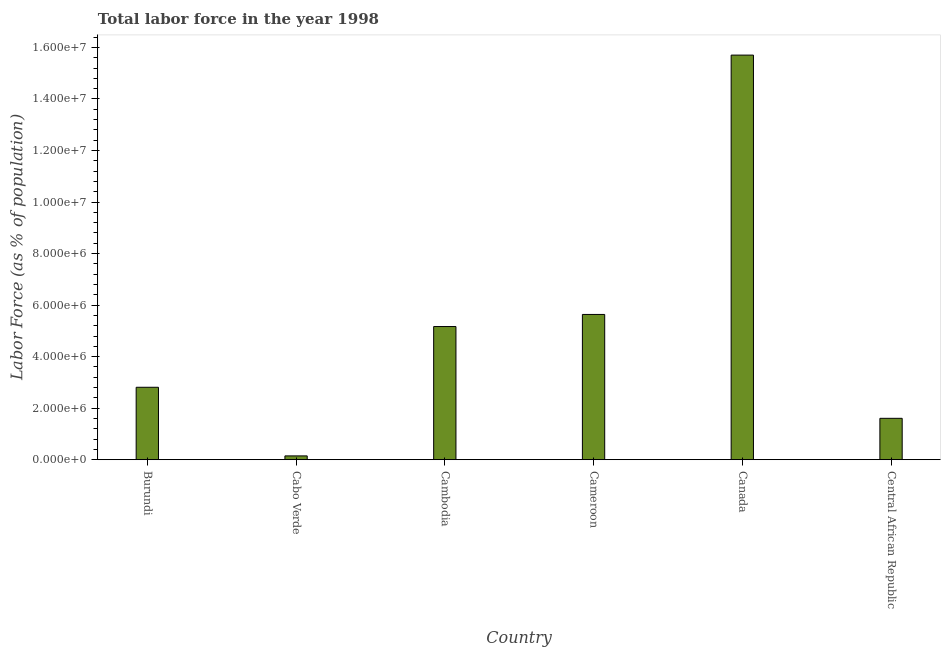Does the graph contain any zero values?
Keep it short and to the point. No. What is the title of the graph?
Your response must be concise. Total labor force in the year 1998. What is the label or title of the Y-axis?
Your answer should be very brief. Labor Force (as % of population). What is the total labor force in Cameroon?
Give a very brief answer. 5.64e+06. Across all countries, what is the maximum total labor force?
Give a very brief answer. 1.57e+07. Across all countries, what is the minimum total labor force?
Make the answer very short. 1.48e+05. In which country was the total labor force minimum?
Provide a succinct answer. Cabo Verde. What is the sum of the total labor force?
Offer a terse response. 3.11e+07. What is the difference between the total labor force in Cambodia and Cameroon?
Provide a short and direct response. -4.70e+05. What is the average total labor force per country?
Provide a short and direct response. 5.18e+06. What is the median total labor force?
Your answer should be compact. 3.99e+06. What is the ratio of the total labor force in Cambodia to that in Cameroon?
Your answer should be very brief. 0.92. Is the total labor force in Canada less than that in Central African Republic?
Offer a terse response. No. What is the difference between the highest and the second highest total labor force?
Give a very brief answer. 1.01e+07. Is the sum of the total labor force in Cabo Verde and Cambodia greater than the maximum total labor force across all countries?
Offer a very short reply. No. What is the difference between the highest and the lowest total labor force?
Your answer should be very brief. 1.56e+07. In how many countries, is the total labor force greater than the average total labor force taken over all countries?
Ensure brevity in your answer.  2. How many bars are there?
Your response must be concise. 6. Are all the bars in the graph horizontal?
Give a very brief answer. No. How many countries are there in the graph?
Your response must be concise. 6. Are the values on the major ticks of Y-axis written in scientific E-notation?
Your answer should be very brief. Yes. What is the Labor Force (as % of population) of Burundi?
Offer a terse response. 2.81e+06. What is the Labor Force (as % of population) of Cabo Verde?
Keep it short and to the point. 1.48e+05. What is the Labor Force (as % of population) of Cambodia?
Keep it short and to the point. 5.17e+06. What is the Labor Force (as % of population) in Cameroon?
Provide a succinct answer. 5.64e+06. What is the Labor Force (as % of population) of Canada?
Provide a succinct answer. 1.57e+07. What is the Labor Force (as % of population) in Central African Republic?
Provide a short and direct response. 1.61e+06. What is the difference between the Labor Force (as % of population) in Burundi and Cabo Verde?
Keep it short and to the point. 2.66e+06. What is the difference between the Labor Force (as % of population) in Burundi and Cambodia?
Ensure brevity in your answer.  -2.36e+06. What is the difference between the Labor Force (as % of population) in Burundi and Cameroon?
Ensure brevity in your answer.  -2.83e+06. What is the difference between the Labor Force (as % of population) in Burundi and Canada?
Offer a terse response. -1.29e+07. What is the difference between the Labor Force (as % of population) in Burundi and Central African Republic?
Provide a short and direct response. 1.21e+06. What is the difference between the Labor Force (as % of population) in Cabo Verde and Cambodia?
Your answer should be very brief. -5.02e+06. What is the difference between the Labor Force (as % of population) in Cabo Verde and Cameroon?
Your answer should be compact. -5.49e+06. What is the difference between the Labor Force (as % of population) in Cabo Verde and Canada?
Ensure brevity in your answer.  -1.56e+07. What is the difference between the Labor Force (as % of population) in Cabo Verde and Central African Republic?
Keep it short and to the point. -1.46e+06. What is the difference between the Labor Force (as % of population) in Cambodia and Cameroon?
Ensure brevity in your answer.  -4.70e+05. What is the difference between the Labor Force (as % of population) in Cambodia and Canada?
Offer a very short reply. -1.05e+07. What is the difference between the Labor Force (as % of population) in Cambodia and Central African Republic?
Make the answer very short. 3.56e+06. What is the difference between the Labor Force (as % of population) in Cameroon and Canada?
Provide a short and direct response. -1.01e+07. What is the difference between the Labor Force (as % of population) in Cameroon and Central African Republic?
Provide a succinct answer. 4.03e+06. What is the difference between the Labor Force (as % of population) in Canada and Central African Republic?
Your response must be concise. 1.41e+07. What is the ratio of the Labor Force (as % of population) in Burundi to that in Cabo Verde?
Keep it short and to the point. 19.04. What is the ratio of the Labor Force (as % of population) in Burundi to that in Cambodia?
Keep it short and to the point. 0.54. What is the ratio of the Labor Force (as % of population) in Burundi to that in Cameroon?
Offer a very short reply. 0.5. What is the ratio of the Labor Force (as % of population) in Burundi to that in Canada?
Ensure brevity in your answer.  0.18. What is the ratio of the Labor Force (as % of population) in Burundi to that in Central African Republic?
Provide a short and direct response. 1.75. What is the ratio of the Labor Force (as % of population) in Cabo Verde to that in Cambodia?
Your answer should be compact. 0.03. What is the ratio of the Labor Force (as % of population) in Cabo Verde to that in Cameroon?
Give a very brief answer. 0.03. What is the ratio of the Labor Force (as % of population) in Cabo Verde to that in Canada?
Keep it short and to the point. 0.01. What is the ratio of the Labor Force (as % of population) in Cabo Verde to that in Central African Republic?
Ensure brevity in your answer.  0.09. What is the ratio of the Labor Force (as % of population) in Cambodia to that in Cameroon?
Offer a terse response. 0.92. What is the ratio of the Labor Force (as % of population) in Cambodia to that in Canada?
Your response must be concise. 0.33. What is the ratio of the Labor Force (as % of population) in Cambodia to that in Central African Republic?
Keep it short and to the point. 3.22. What is the ratio of the Labor Force (as % of population) in Cameroon to that in Canada?
Provide a short and direct response. 0.36. What is the ratio of the Labor Force (as % of population) in Cameroon to that in Central African Republic?
Your answer should be very brief. 3.51. What is the ratio of the Labor Force (as % of population) in Canada to that in Central African Republic?
Ensure brevity in your answer.  9.78. 